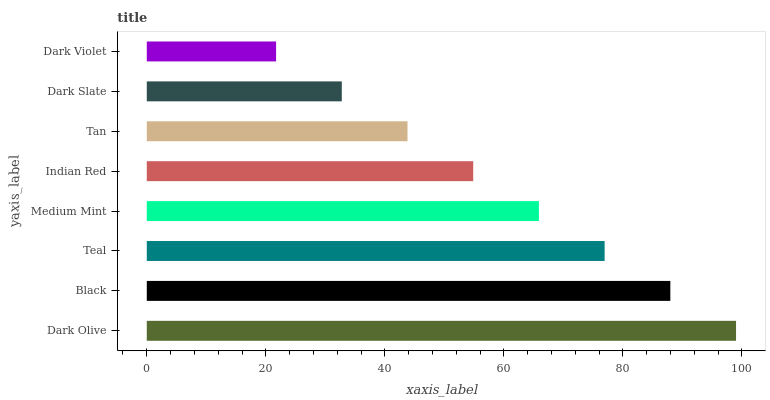Is Dark Violet the minimum?
Answer yes or no. Yes. Is Dark Olive the maximum?
Answer yes or no. Yes. Is Black the minimum?
Answer yes or no. No. Is Black the maximum?
Answer yes or no. No. Is Dark Olive greater than Black?
Answer yes or no. Yes. Is Black less than Dark Olive?
Answer yes or no. Yes. Is Black greater than Dark Olive?
Answer yes or no. No. Is Dark Olive less than Black?
Answer yes or no. No. Is Medium Mint the high median?
Answer yes or no. Yes. Is Indian Red the low median?
Answer yes or no. Yes. Is Tan the high median?
Answer yes or no. No. Is Tan the low median?
Answer yes or no. No. 